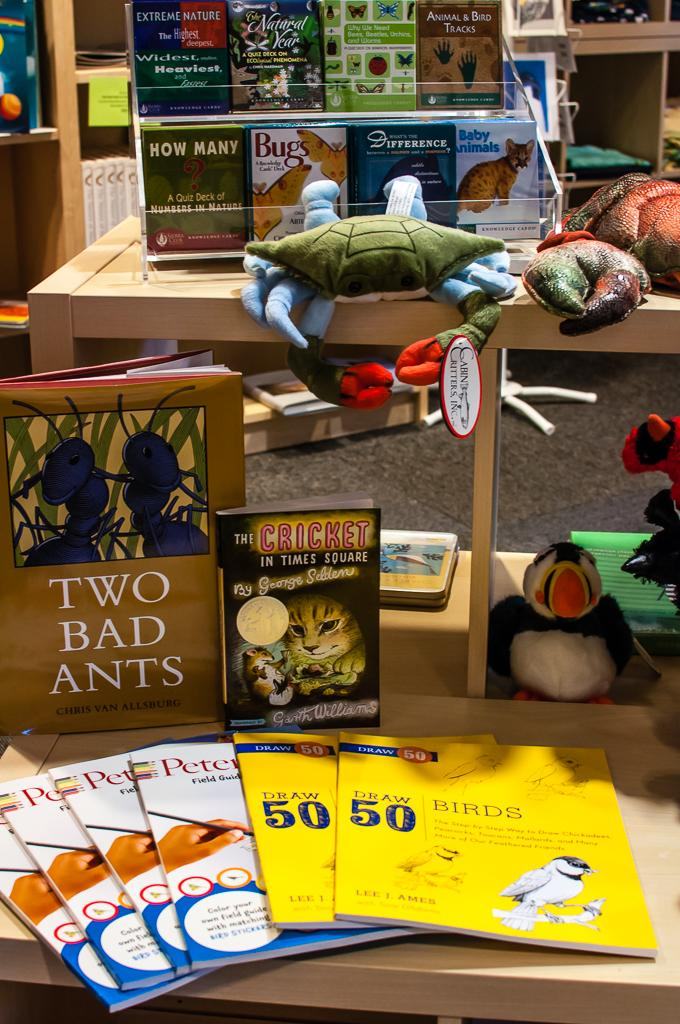<image>
Present a compact description of the photo's key features. A book display with Two Bad Ants is surrounded by stuffed animals. 